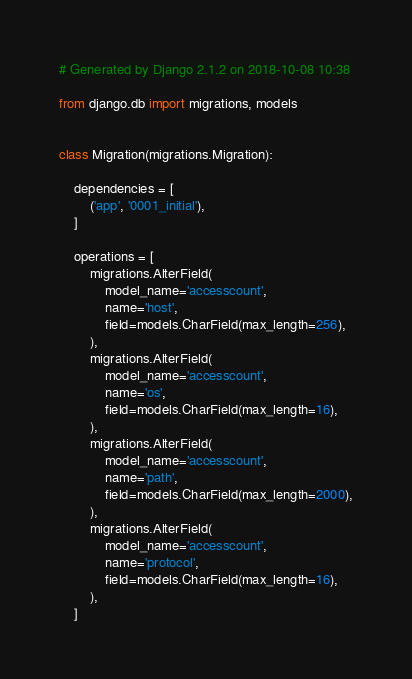<code> <loc_0><loc_0><loc_500><loc_500><_Python_># Generated by Django 2.1.2 on 2018-10-08 10:38

from django.db import migrations, models


class Migration(migrations.Migration):

    dependencies = [
        ('app', '0001_initial'),
    ]

    operations = [
        migrations.AlterField(
            model_name='accesscount',
            name='host',
            field=models.CharField(max_length=256),
        ),
        migrations.AlterField(
            model_name='accesscount',
            name='os',
            field=models.CharField(max_length=16),
        ),
        migrations.AlterField(
            model_name='accesscount',
            name='path',
            field=models.CharField(max_length=2000),
        ),
        migrations.AlterField(
            model_name='accesscount',
            name='protocol',
            field=models.CharField(max_length=16),
        ),
    ]
</code> 